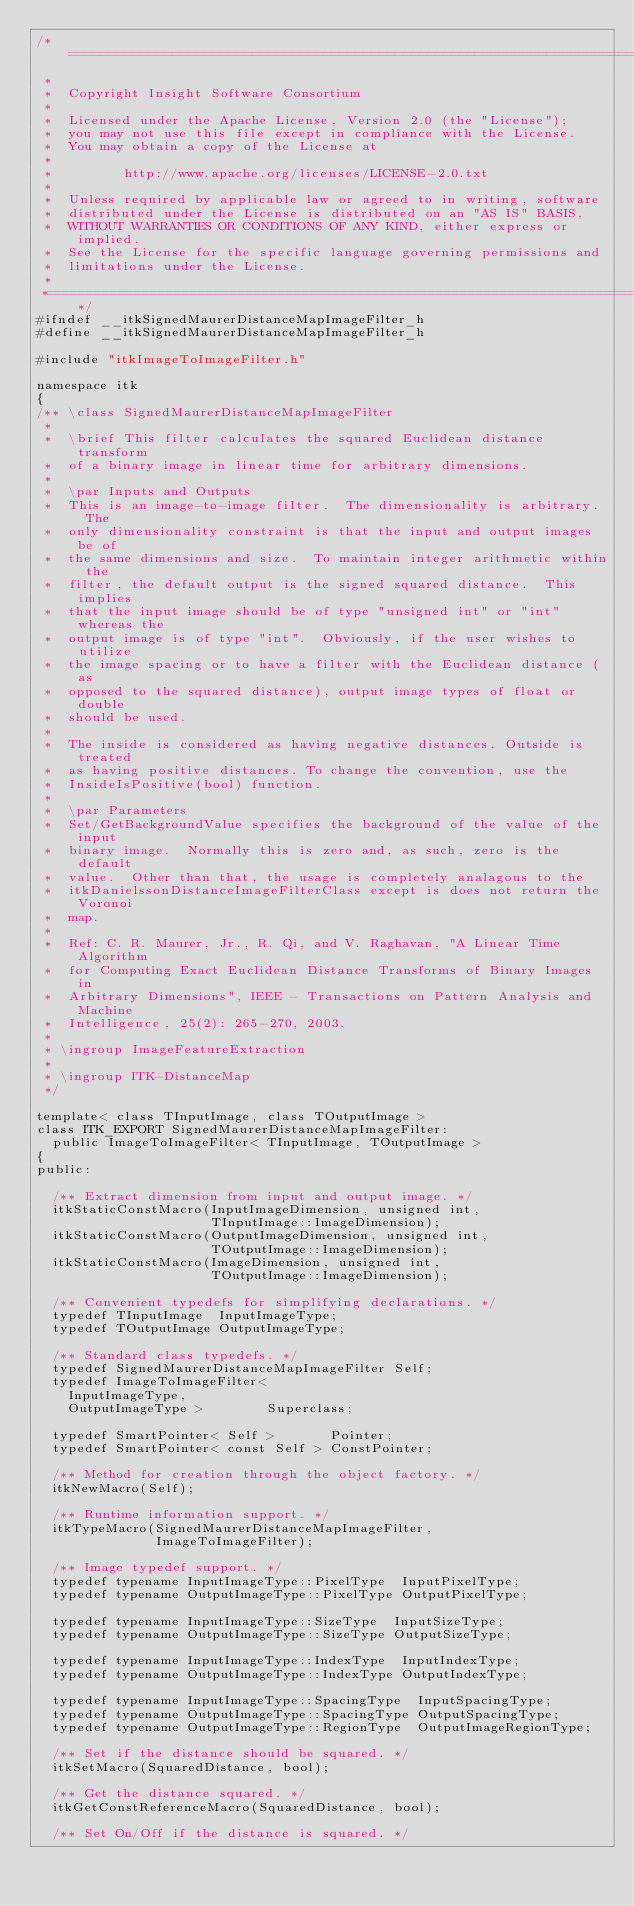Convert code to text. <code><loc_0><loc_0><loc_500><loc_500><_C_>/*=========================================================================
 *
 *  Copyright Insight Software Consortium
 *
 *  Licensed under the Apache License, Version 2.0 (the "License");
 *  you may not use this file except in compliance with the License.
 *  You may obtain a copy of the License at
 *
 *         http://www.apache.org/licenses/LICENSE-2.0.txt
 *
 *  Unless required by applicable law or agreed to in writing, software
 *  distributed under the License is distributed on an "AS IS" BASIS,
 *  WITHOUT WARRANTIES OR CONDITIONS OF ANY KIND, either express or implied.
 *  See the License for the specific language governing permissions and
 *  limitations under the License.
 *
 *=========================================================================*/
#ifndef __itkSignedMaurerDistanceMapImageFilter_h
#define __itkSignedMaurerDistanceMapImageFilter_h

#include "itkImageToImageFilter.h"

namespace itk
{
/** \class SignedMaurerDistanceMapImageFilter
 *
 *  \brief This filter calculates the squared Euclidean distance transform
 *  of a binary image in linear time for arbitrary dimensions.
 *
 *  \par Inputs and Outputs
 *  This is an image-to-image filter.  The dimensionality is arbitrary.  The
 *  only dimensionality constraint is that the input and output images be of
 *  the same dimensions and size.  To maintain integer arithmetic within the
 *  filter, the default output is the signed squared distance.  This implies
 *  that the input image should be of type "unsigned int" or "int" whereas the
 *  output image is of type "int".  Obviously, if the user wishes to utilize
 *  the image spacing or to have a filter with the Euclidean distance (as
 *  opposed to the squared distance), output image types of float or double
 *  should be used.
 *
 *  The inside is considered as having negative distances. Outside is treated
 *  as having positive distances. To change the convention, use the
 *  InsideIsPositive(bool) function.
 *
 *  \par Parameters
 *  Set/GetBackgroundValue specifies the background of the value of the input
 *  binary image.  Normally this is zero and, as such, zero is the default
 *  value.  Other than that, the usage is completely analagous to the
 *  itkDanielssonDistanceImageFilterClass except is does not return the Voronoi
 *  map.
 *
 *  Ref: C. R. Maurer, Jr., R. Qi, and V. Raghavan, "A Linear Time Algorithm
 *  for Computing Exact Euclidean Distance Transforms of Binary Images in
 *  Arbitrary Dimensions", IEEE - Transactions on Pattern Analysis and Machine
 *  Intelligence, 25(2): 265-270, 2003.
 *
 * \ingroup ImageFeatureExtraction
 *
 * \ingroup ITK-DistanceMap
 */

template< class TInputImage, class TOutputImage >
class ITK_EXPORT SignedMaurerDistanceMapImageFilter:
  public ImageToImageFilter< TInputImage, TOutputImage >
{
public:

  /** Extract dimension from input and output image. */
  itkStaticConstMacro(InputImageDimension, unsigned int,
                      TInputImage::ImageDimension);
  itkStaticConstMacro(OutputImageDimension, unsigned int,
                      TOutputImage::ImageDimension);
  itkStaticConstMacro(ImageDimension, unsigned int,
                      TOutputImage::ImageDimension);

  /** Convenient typedefs for simplifying declarations. */
  typedef TInputImage  InputImageType;
  typedef TOutputImage OutputImageType;

  /** Standard class typedefs. */
  typedef SignedMaurerDistanceMapImageFilter Self;
  typedef ImageToImageFilter<
    InputImageType,
    OutputImageType >        Superclass;

  typedef SmartPointer< Self >       Pointer;
  typedef SmartPointer< const Self > ConstPointer;

  /** Method for creation through the object factory. */
  itkNewMacro(Self);

  /** Runtime information support. */
  itkTypeMacro(SignedMaurerDistanceMapImageFilter,
               ImageToImageFilter);

  /** Image typedef support. */
  typedef typename InputImageType::PixelType  InputPixelType;
  typedef typename OutputImageType::PixelType OutputPixelType;

  typedef typename InputImageType::SizeType  InputSizeType;
  typedef typename OutputImageType::SizeType OutputSizeType;

  typedef typename InputImageType::IndexType  InputIndexType;
  typedef typename OutputImageType::IndexType OutputIndexType;

  typedef typename InputImageType::SpacingType  InputSpacingType;
  typedef typename OutputImageType::SpacingType OutputSpacingType;
  typedef typename OutputImageType::RegionType  OutputImageRegionType;

  /** Set if the distance should be squared. */
  itkSetMacro(SquaredDistance, bool);

  /** Get the distance squared. */
  itkGetConstReferenceMacro(SquaredDistance, bool);

  /** Set On/Off if the distance is squared. */</code> 